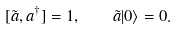Convert formula to latex. <formula><loc_0><loc_0><loc_500><loc_500>[ \tilde { a } , a ^ { \dagger } ] = 1 , \quad \tilde { a } | 0 \rangle = 0 .</formula> 